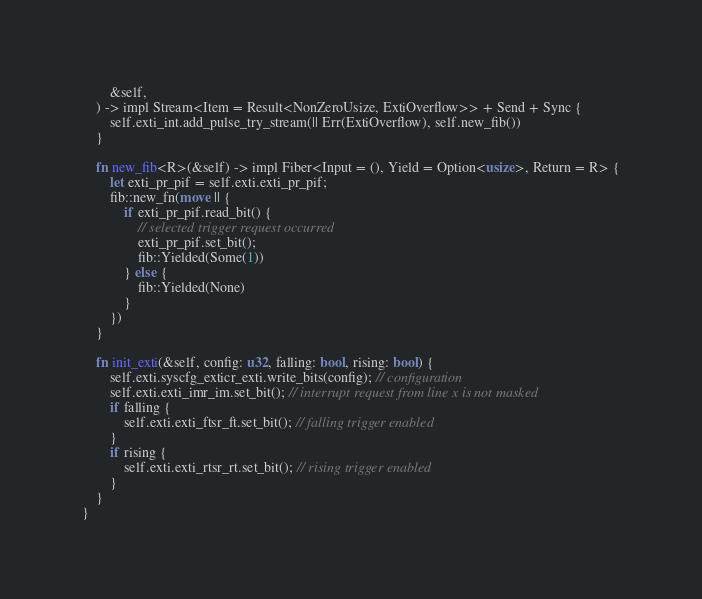Convert code to text. <code><loc_0><loc_0><loc_500><loc_500><_Rust_>        &self,
    ) -> impl Stream<Item = Result<NonZeroUsize, ExtiOverflow>> + Send + Sync {
        self.exti_int.add_pulse_try_stream(|| Err(ExtiOverflow), self.new_fib())
    }

    fn new_fib<R>(&self) -> impl Fiber<Input = (), Yield = Option<usize>, Return = R> {
        let exti_pr_pif = self.exti.exti_pr_pif;
        fib::new_fn(move || {
            if exti_pr_pif.read_bit() {
                // selected trigger request occurred
                exti_pr_pif.set_bit();
                fib::Yielded(Some(1))
            } else {
                fib::Yielded(None)
            }
        })
    }

    fn init_exti(&self, config: u32, falling: bool, rising: bool) {
        self.exti.syscfg_exticr_exti.write_bits(config); // configuration
        self.exti.exti_imr_im.set_bit(); // interrupt request from line x is not masked
        if falling {
            self.exti.exti_ftsr_ft.set_bit(); // falling trigger enabled
        }
        if rising {
            self.exti.exti_rtsr_rt.set_bit(); // rising trigger enabled
        }
    }
}
</code> 